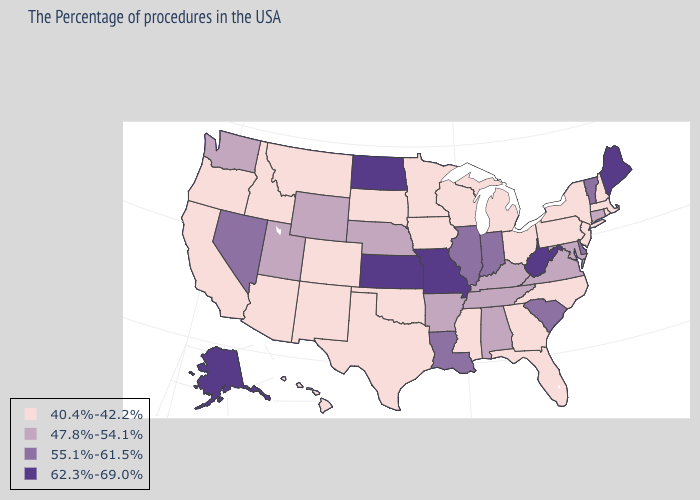Does Alaska have the highest value in the USA?
Keep it brief. Yes. Does the first symbol in the legend represent the smallest category?
Answer briefly. Yes. Which states have the highest value in the USA?
Short answer required. Maine, West Virginia, Missouri, Kansas, North Dakota, Alaska. What is the value of North Dakota?
Quick response, please. 62.3%-69.0%. Which states hav the highest value in the South?
Answer briefly. West Virginia. Which states have the lowest value in the Northeast?
Write a very short answer. Massachusetts, Rhode Island, New Hampshire, New York, New Jersey, Pennsylvania. What is the highest value in the USA?
Be succinct. 62.3%-69.0%. Name the states that have a value in the range 40.4%-42.2%?
Concise answer only. Massachusetts, Rhode Island, New Hampshire, New York, New Jersey, Pennsylvania, North Carolina, Ohio, Florida, Georgia, Michigan, Wisconsin, Mississippi, Minnesota, Iowa, Oklahoma, Texas, South Dakota, Colorado, New Mexico, Montana, Arizona, Idaho, California, Oregon, Hawaii. How many symbols are there in the legend?
Be succinct. 4. What is the lowest value in states that border Illinois?
Be succinct. 40.4%-42.2%. Is the legend a continuous bar?
Give a very brief answer. No. What is the highest value in states that border Maryland?
Give a very brief answer. 62.3%-69.0%. Name the states that have a value in the range 62.3%-69.0%?
Keep it brief. Maine, West Virginia, Missouri, Kansas, North Dakota, Alaska. What is the value of Connecticut?
Quick response, please. 47.8%-54.1%. 